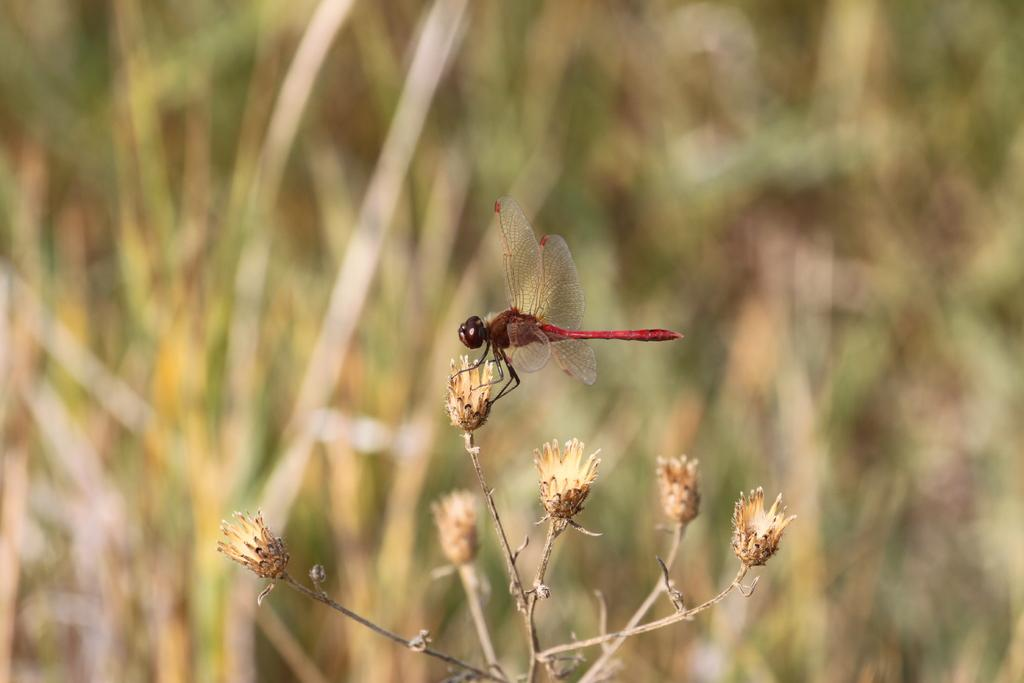What is the main subject of the image? The main subject of the image is a dried stem with unbloomed flowers. Are there any insects present in the image? Yes, there is a fly on the stem or flowers. What type of notebook is being used by the students in the image? There are no students or notebooks present in the image; it features a dried stem with unbloomed flowers and a fly. 